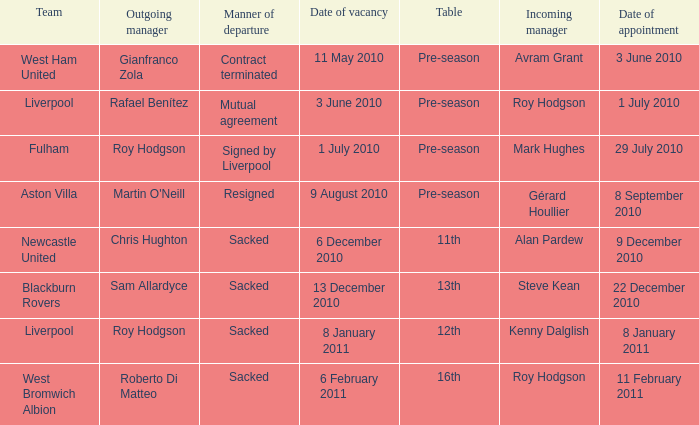When was the joining date for the incoming manager, roy hodgson, with the liverpool squad? 1 July 2010. 